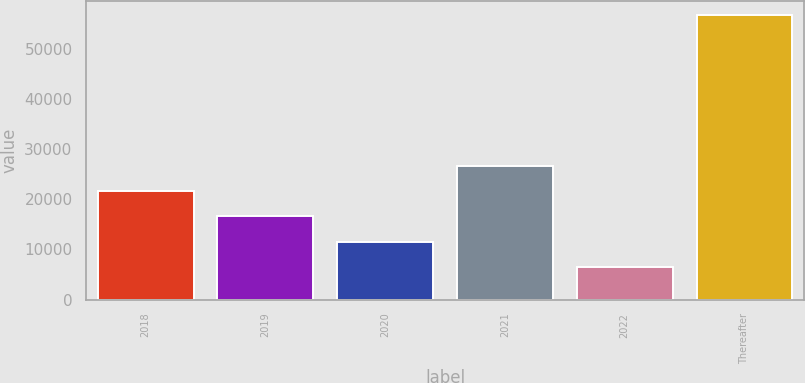<chart> <loc_0><loc_0><loc_500><loc_500><bar_chart><fcel>2018<fcel>2019<fcel>2020<fcel>2021<fcel>2022<fcel>Thereafter<nl><fcel>21635<fcel>16602<fcel>11569<fcel>26668<fcel>6536<fcel>56866<nl></chart> 